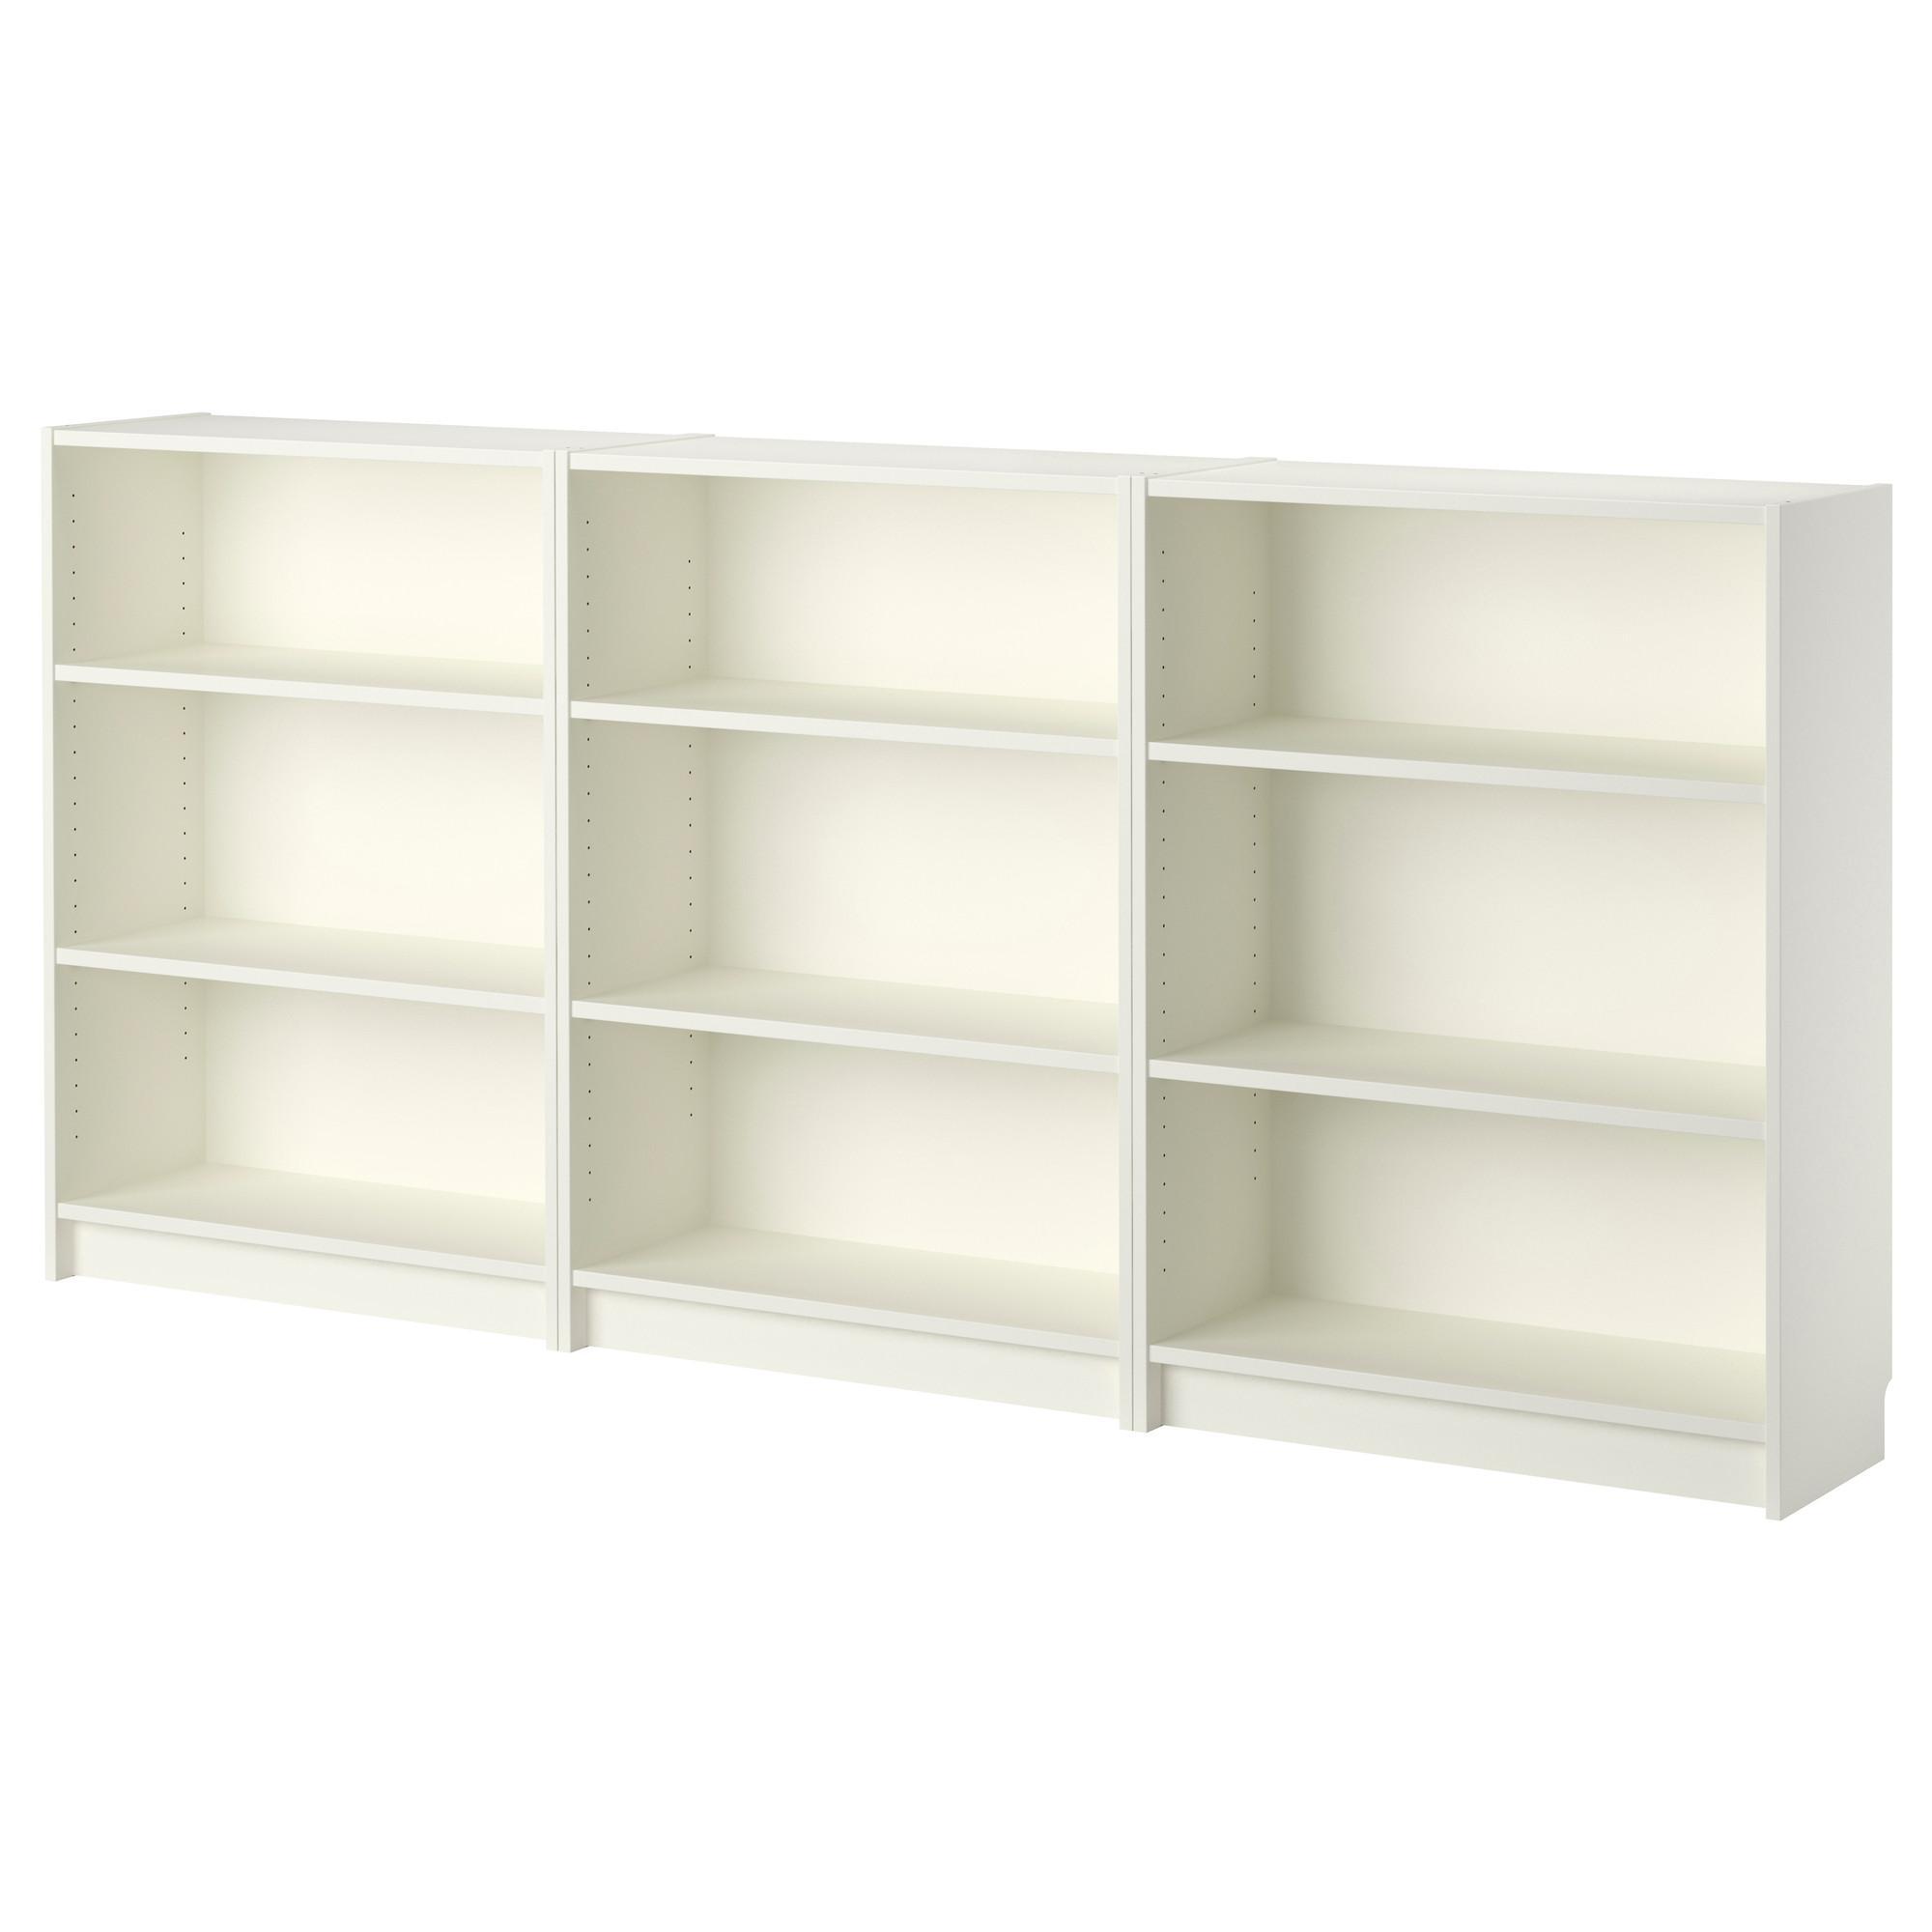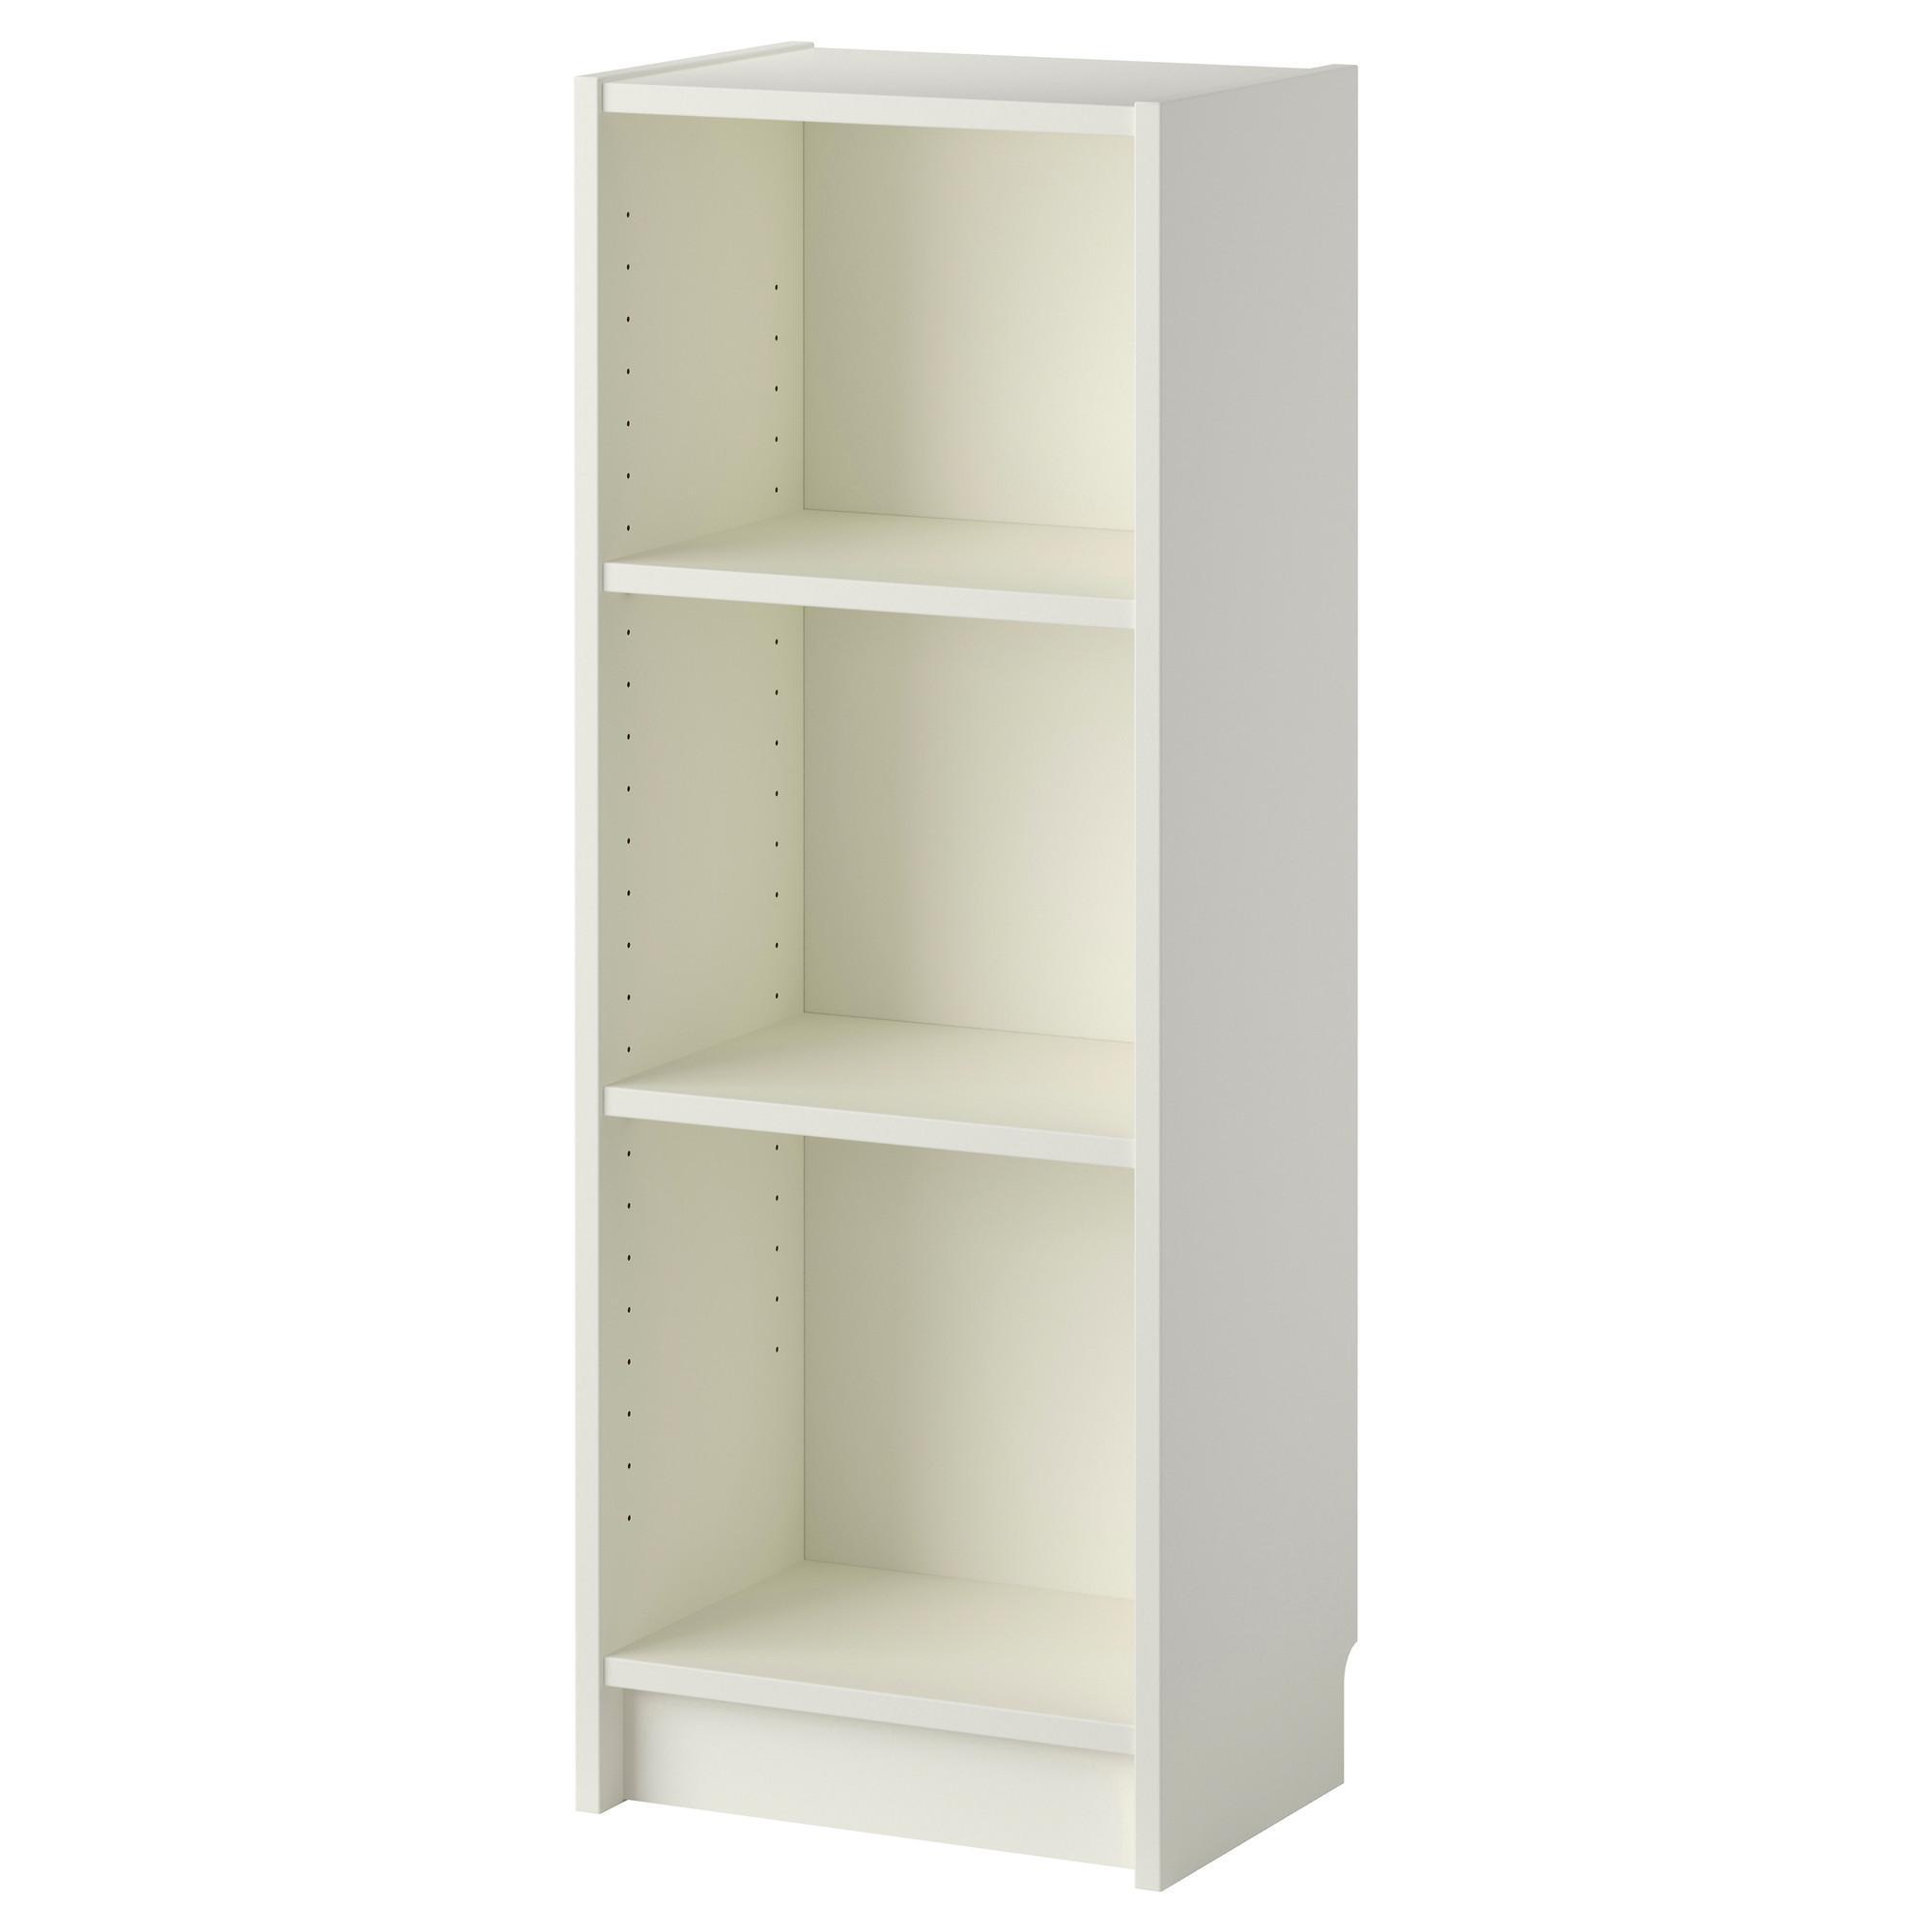The first image is the image on the left, the second image is the image on the right. For the images displayed, is the sentence "At least one of the images shows an empty bookcase." factually correct? Answer yes or no. Yes. 